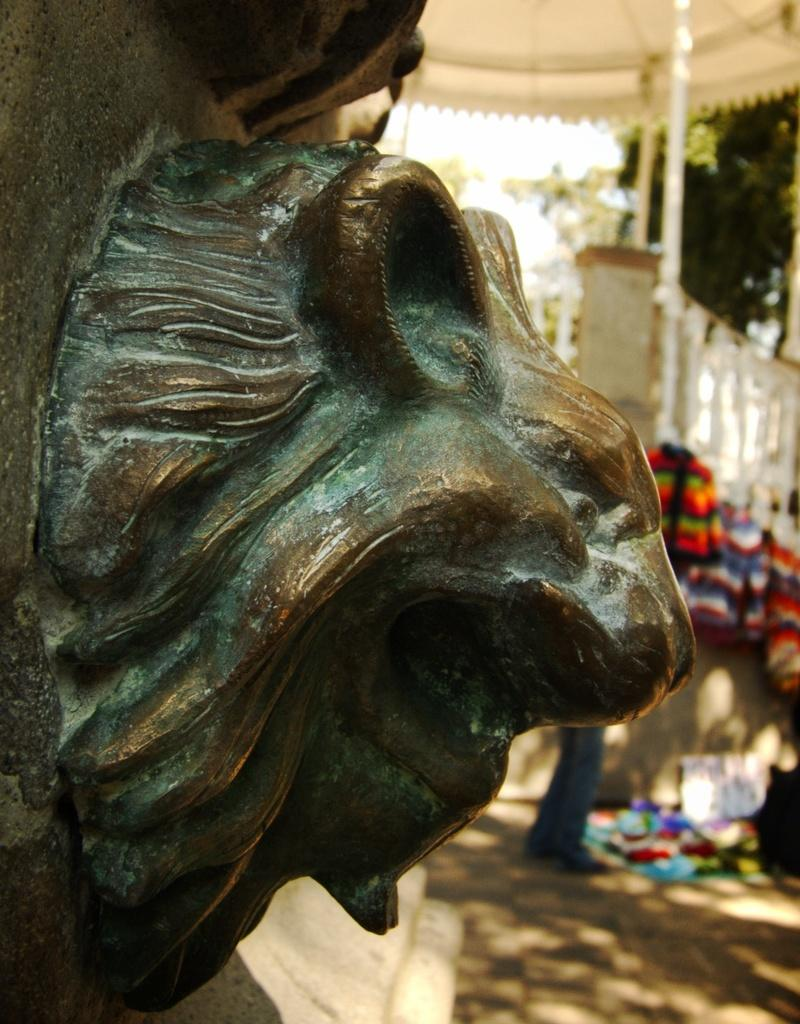What is the main subject in the image? There is a statue in the image. What can be seen behind the statue? There are clothes and trees visible behind the statue. What type of structure is present in the image? There is a white roof in the image. What other object can be seen in the image? There is a pole in the image. Are there any people in the image? Yes, there are people on the ground in the image. What type of brush is being used by the person in the image? There is no person using a brush in the image; it features a statue and other elements. 